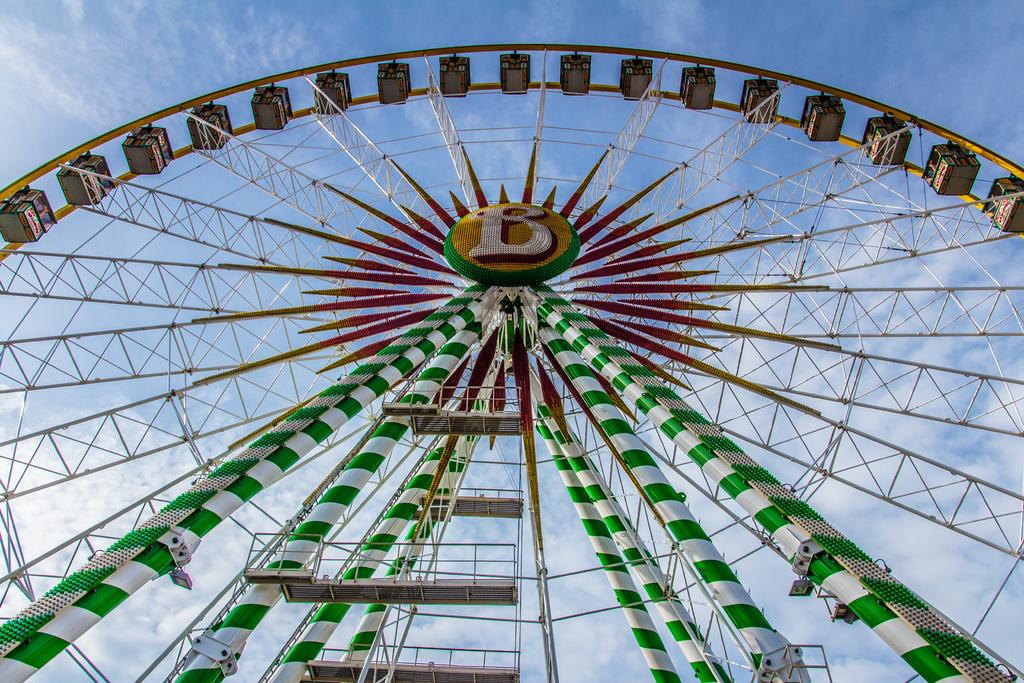What is the main subject of the image? There is a giant wheel in the image. What can be seen in the background of the image? There are clouds in the background of the image. What color is the sky in the image? The sky is blue in the image. Reasoning: Let' Let's think step by step in order to produce the conversation. We start by identifying the main subject of the image, which is the giant wheel. Then, we describe the background of the image, which includes clouds. Finally, we mention the color of the sky, which is blue. Each question is designed to elicit a specific detail about the image that is known from the provided facts. Absurd Question/Answer: How many vans are parked near the giant wheel in the image? There are no vans present in the image; it only features a giant wheel and clouds in the background. What type of crib is visible in the image? There is no crib present in the image. 